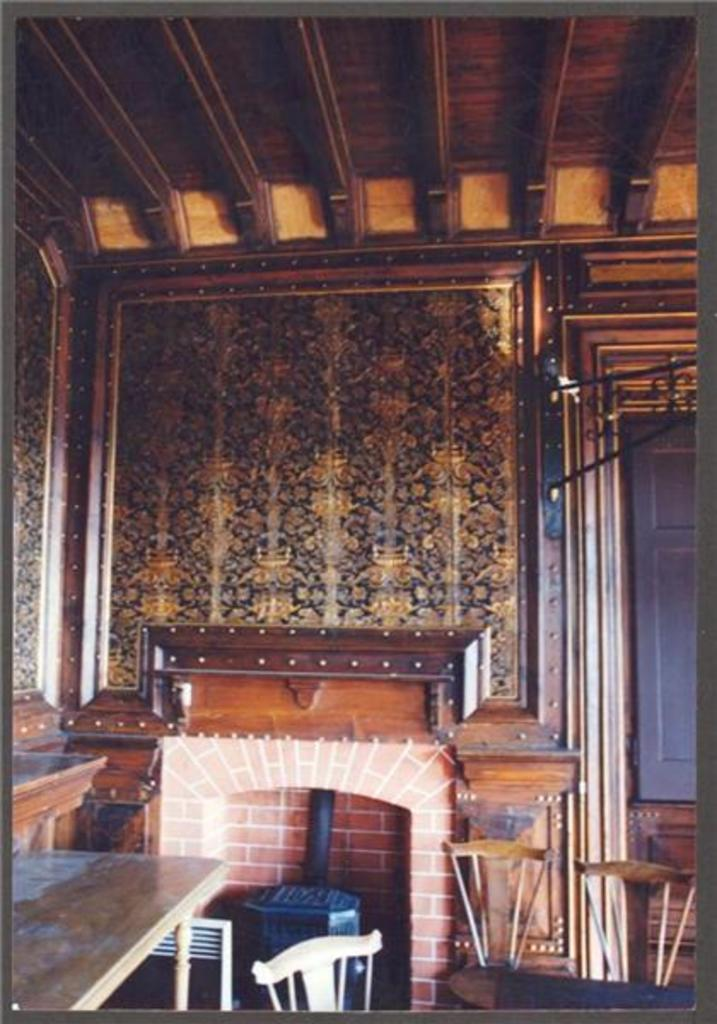What type of heating element can be found in the room? There is a fireplace in the room. What type of furniture is present in the room? There are chairs and tables in the room. What material is used for the roof of the room? The roof of the room is made of wood. What scent can be detected in the room from the fireplace? The image does not provide information about the scent in the room, so it cannot be determined from the image. 